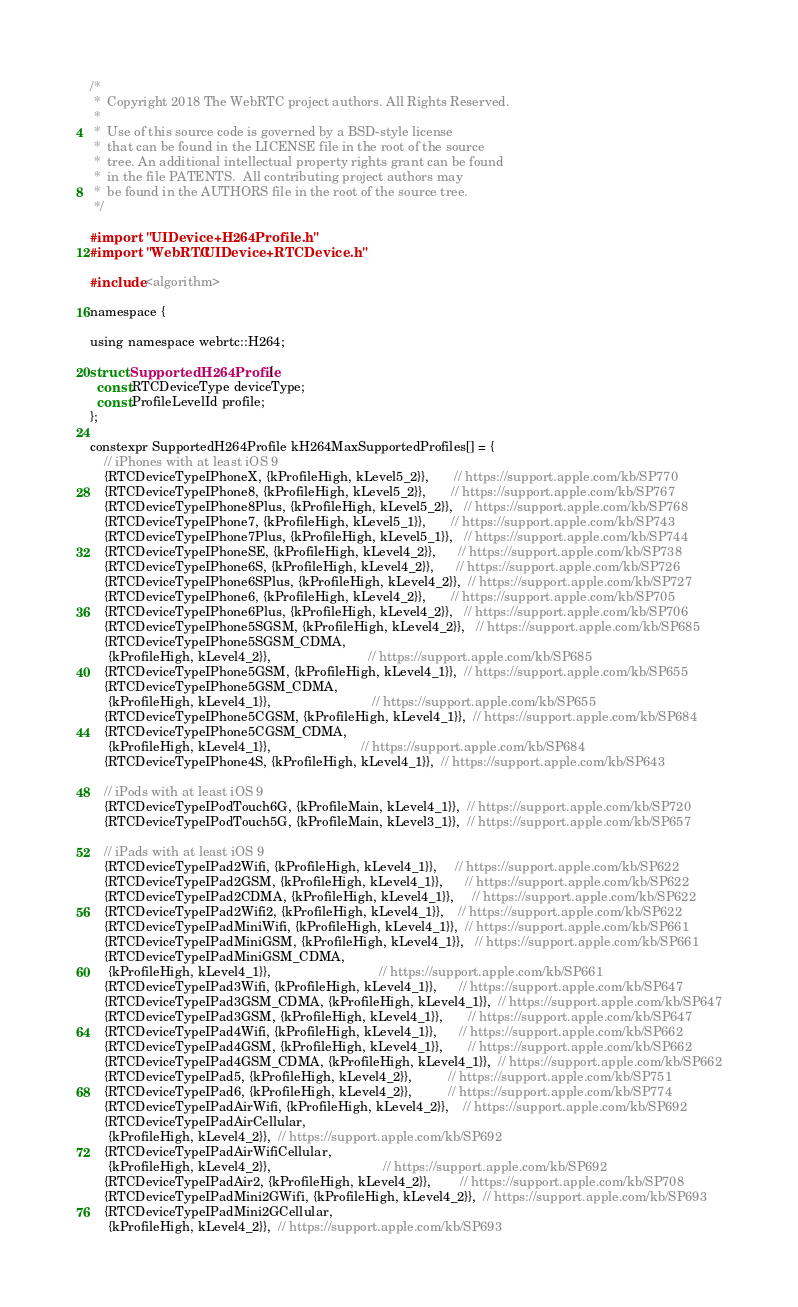Convert code to text. <code><loc_0><loc_0><loc_500><loc_500><_ObjectiveC_>/*
 *  Copyright 2018 The WebRTC project authors. All Rights Reserved.
 *
 *  Use of this source code is governed by a BSD-style license
 *  that can be found in the LICENSE file in the root of the source
 *  tree. An additional intellectual property rights grant can be found
 *  in the file PATENTS.  All contributing project authors may
 *  be found in the AUTHORS file in the root of the source tree.
 */

#import "UIDevice+H264Profile.h"
#import "WebRTC/UIDevice+RTCDevice.h"

#include <algorithm>

namespace {

using namespace webrtc::H264;

struct SupportedH264Profile {
  const RTCDeviceType deviceType;
  const ProfileLevelId profile;
};

constexpr SupportedH264Profile kH264MaxSupportedProfiles[] = {
    // iPhones with at least iOS 9
    {RTCDeviceTypeIPhoneX, {kProfileHigh, kLevel5_2}},       // https://support.apple.com/kb/SP770
    {RTCDeviceTypeIPhone8, {kProfileHigh, kLevel5_2}},       // https://support.apple.com/kb/SP767
    {RTCDeviceTypeIPhone8Plus, {kProfileHigh, kLevel5_2}},   // https://support.apple.com/kb/SP768
    {RTCDeviceTypeIPhone7, {kProfileHigh, kLevel5_1}},       // https://support.apple.com/kb/SP743
    {RTCDeviceTypeIPhone7Plus, {kProfileHigh, kLevel5_1}},   // https://support.apple.com/kb/SP744
    {RTCDeviceTypeIPhoneSE, {kProfileHigh, kLevel4_2}},      // https://support.apple.com/kb/SP738
    {RTCDeviceTypeIPhone6S, {kProfileHigh, kLevel4_2}},      // https://support.apple.com/kb/SP726
    {RTCDeviceTypeIPhone6SPlus, {kProfileHigh, kLevel4_2}},  // https://support.apple.com/kb/SP727
    {RTCDeviceTypeIPhone6, {kProfileHigh, kLevel4_2}},       // https://support.apple.com/kb/SP705
    {RTCDeviceTypeIPhone6Plus, {kProfileHigh, kLevel4_2}},   // https://support.apple.com/kb/SP706
    {RTCDeviceTypeIPhone5SGSM, {kProfileHigh, kLevel4_2}},   // https://support.apple.com/kb/SP685
    {RTCDeviceTypeIPhone5SGSM_CDMA,
     {kProfileHigh, kLevel4_2}},                           // https://support.apple.com/kb/SP685
    {RTCDeviceTypeIPhone5GSM, {kProfileHigh, kLevel4_1}},  // https://support.apple.com/kb/SP655
    {RTCDeviceTypeIPhone5GSM_CDMA,
     {kProfileHigh, kLevel4_1}},                            // https://support.apple.com/kb/SP655
    {RTCDeviceTypeIPhone5CGSM, {kProfileHigh, kLevel4_1}},  // https://support.apple.com/kb/SP684
    {RTCDeviceTypeIPhone5CGSM_CDMA,
     {kProfileHigh, kLevel4_1}},                         // https://support.apple.com/kb/SP684
    {RTCDeviceTypeIPhone4S, {kProfileHigh, kLevel4_1}},  // https://support.apple.com/kb/SP643

    // iPods with at least iOS 9
    {RTCDeviceTypeIPodTouch6G, {kProfileMain, kLevel4_1}},  // https://support.apple.com/kb/SP720
    {RTCDeviceTypeIPodTouch5G, {kProfileMain, kLevel3_1}},  // https://support.apple.com/kb/SP657

    // iPads with at least iOS 9
    {RTCDeviceTypeIPad2Wifi, {kProfileHigh, kLevel4_1}},     // https://support.apple.com/kb/SP622
    {RTCDeviceTypeIPad2GSM, {kProfileHigh, kLevel4_1}},      // https://support.apple.com/kb/SP622
    {RTCDeviceTypeIPad2CDMA, {kProfileHigh, kLevel4_1}},     // https://support.apple.com/kb/SP622
    {RTCDeviceTypeIPad2Wifi2, {kProfileHigh, kLevel4_1}},    // https://support.apple.com/kb/SP622
    {RTCDeviceTypeIPadMiniWifi, {kProfileHigh, kLevel4_1}},  // https://support.apple.com/kb/SP661
    {RTCDeviceTypeIPadMiniGSM, {kProfileHigh, kLevel4_1}},   // https://support.apple.com/kb/SP661
    {RTCDeviceTypeIPadMiniGSM_CDMA,
     {kProfileHigh, kLevel4_1}},                              // https://support.apple.com/kb/SP661
    {RTCDeviceTypeIPad3Wifi, {kProfileHigh, kLevel4_1}},      // https://support.apple.com/kb/SP647
    {RTCDeviceTypeIPad3GSM_CDMA, {kProfileHigh, kLevel4_1}},  // https://support.apple.com/kb/SP647
    {RTCDeviceTypeIPad3GSM, {kProfileHigh, kLevel4_1}},       // https://support.apple.com/kb/SP647
    {RTCDeviceTypeIPad4Wifi, {kProfileHigh, kLevel4_1}},      // https://support.apple.com/kb/SP662
    {RTCDeviceTypeIPad4GSM, {kProfileHigh, kLevel4_1}},       // https://support.apple.com/kb/SP662
    {RTCDeviceTypeIPad4GSM_CDMA, {kProfileHigh, kLevel4_1}},  // https://support.apple.com/kb/SP662
    {RTCDeviceTypeIPad5, {kProfileHigh, kLevel4_2}},          // https://support.apple.com/kb/SP751
    {RTCDeviceTypeIPad6, {kProfileHigh, kLevel4_2}},          // https://support.apple.com/kb/SP774
    {RTCDeviceTypeIPadAirWifi, {kProfileHigh, kLevel4_2}},    // https://support.apple.com/kb/SP692
    {RTCDeviceTypeIPadAirCellular,
     {kProfileHigh, kLevel4_2}},  // https://support.apple.com/kb/SP692
    {RTCDeviceTypeIPadAirWifiCellular,
     {kProfileHigh, kLevel4_2}},                               // https://support.apple.com/kb/SP692
    {RTCDeviceTypeIPadAir2, {kProfileHigh, kLevel4_2}},        // https://support.apple.com/kb/SP708
    {RTCDeviceTypeIPadMini2GWifi, {kProfileHigh, kLevel4_2}},  // https://support.apple.com/kb/SP693
    {RTCDeviceTypeIPadMini2GCellular,
     {kProfileHigh, kLevel4_2}},  // https://support.apple.com/kb/SP693</code> 